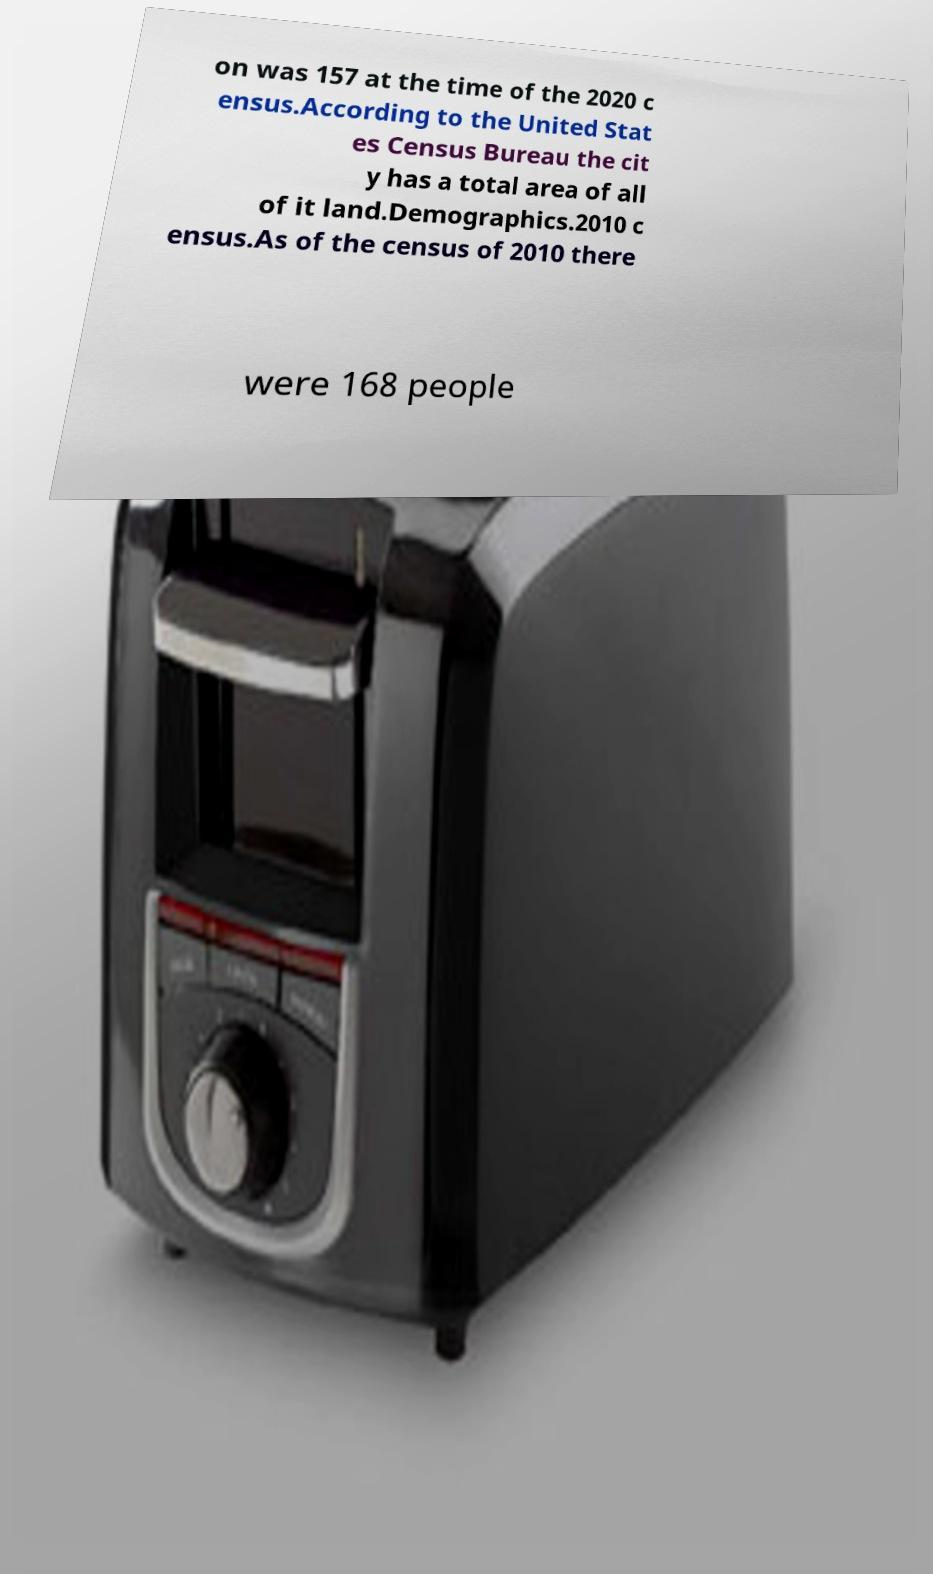Could you extract and type out the text from this image? on was 157 at the time of the 2020 c ensus.According to the United Stat es Census Bureau the cit y has a total area of all of it land.Demographics.2010 c ensus.As of the census of 2010 there were 168 people 